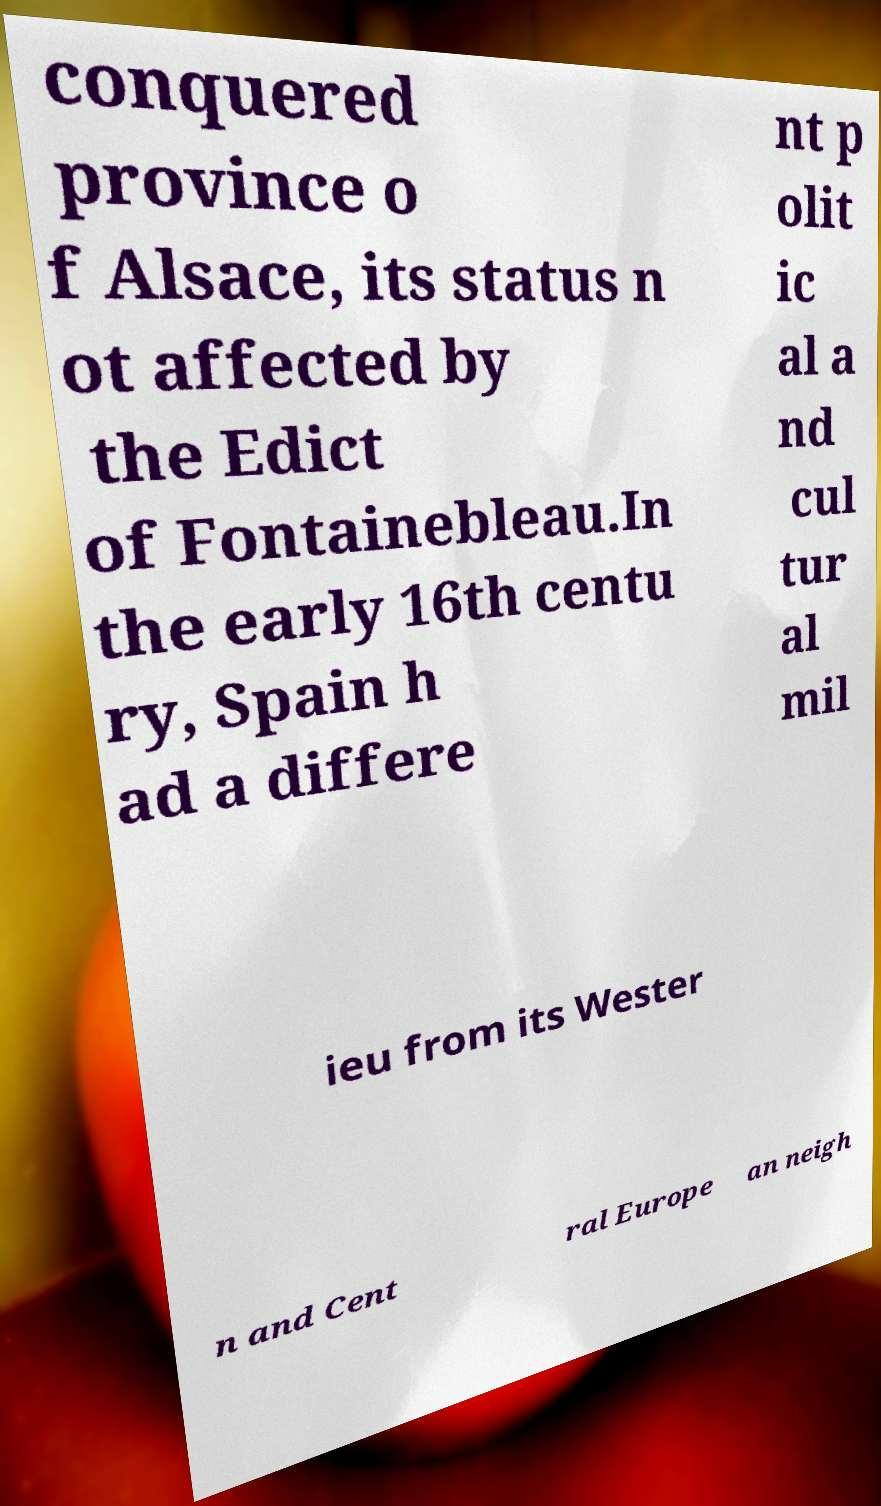What messages or text are displayed in this image? I need them in a readable, typed format. conquered province o f Alsace, its status n ot affected by the Edict of Fontainebleau.In the early 16th centu ry, Spain h ad a differe nt p olit ic al a nd cul tur al mil ieu from its Wester n and Cent ral Europe an neigh 